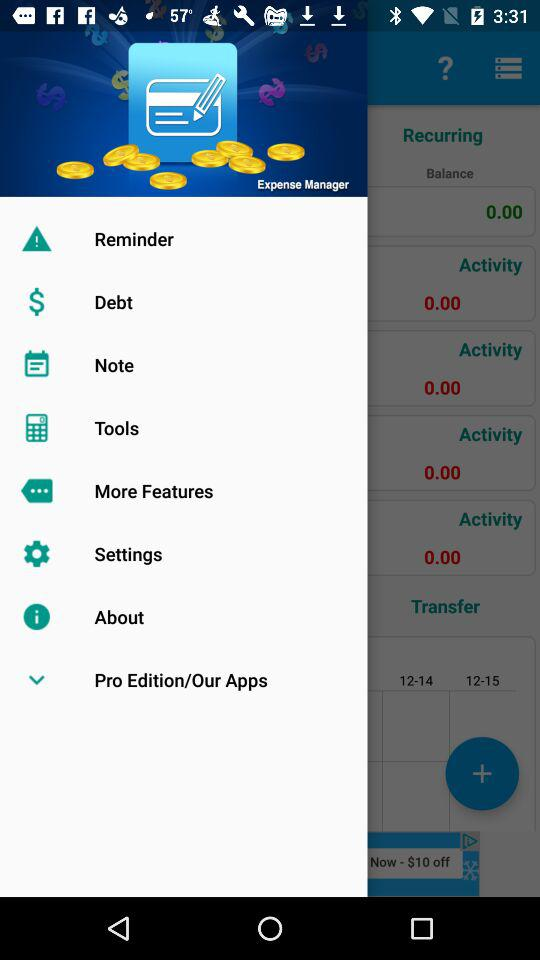What is the name of the application? The name of the application is "Expense Manager". 